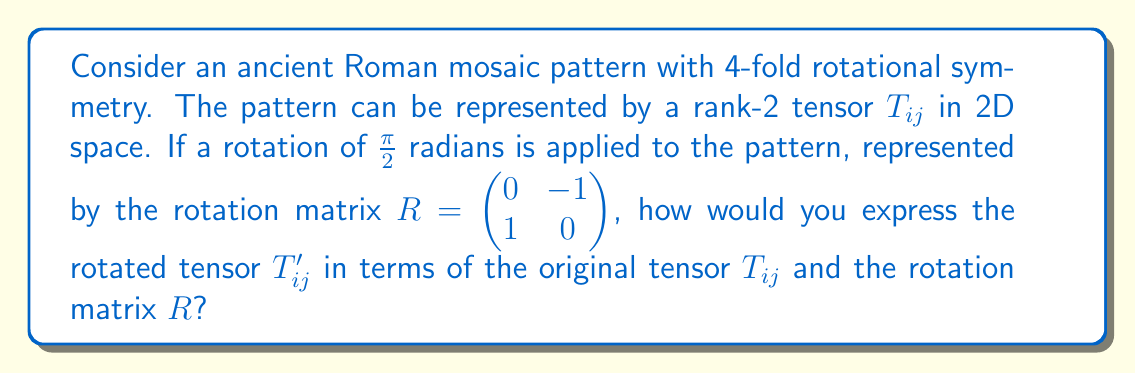Show me your answer to this math problem. To analyze the symmetry of the ancient Roman mosaic pattern using tensor operations, we'll follow these steps:

1) The rotation of a rank-2 tensor $T_{ij}$ by a rotation matrix $R$ is given by the transformation law:

   $$T'_{ij} = R_{im} R_{jn} T_{mn}$$

   Where Einstein summation convention is used (repeated indices are summed over).

2) We're given the rotation matrix $R = \begin{pmatrix} 0 & -1 \\ 1 & 0 \end{pmatrix}$

3) Let's expand the transformation equation:

   $$T'_{ij} = R_{i1} R_{j1} T_{11} + R_{i1} R_{j2} T_{12} + R_{i2} R_{j1} T_{21} + R_{i2} R_{j2} T_{22}$$

4) Now, let's calculate each component of $T'_{ij}$:

   For $T'_{11}$: 
   $$T'_{11} = R_{11} R_{11} T_{11} + R_{11} R_{12} T_{12} + R_{12} R_{11} T_{21} + R_{12} R_{12} T_{22}$$
   $$= (0)(0)T_{11} + (0)(-1)T_{12} + (-1)(0)T_{21} + (-1)(-1)T_{22} = T_{22}$$

   For $T'_{12}$:
   $$T'_{12} = R_{11} R_{21} T_{11} + R_{11} R_{22} T_{12} + R_{12} R_{21} T_{21} + R_{12} R_{22} T_{22}$$
   $$= (0)(1)T_{11} + (0)(0)T_{12} + (-1)(1)T_{21} + (-1)(0)T_{22} = -T_{21}$$

   For $T'_{21}$:
   $$T'_{21} = R_{21} R_{11} T_{11} + R_{21} R_{12} T_{12} + R_{22} R_{11} T_{21} + R_{22} R_{12} T_{22}$$
   $$= (1)(0)T_{11} + (1)(-1)T_{12} + (0)(0)T_{21} + (0)(-1)T_{22} = -T_{12}$$

   For $T'_{22}$:
   $$T'_{22} = R_{21} R_{21} T_{11} + R_{21} R_{22} T_{12} + R_{22} R_{21} T_{21} + R_{22} R_{22} T_{22}$$
   $$= (1)(1)T_{11} + (1)(0)T_{12} + (0)(1)T_{21} + (0)(0)T_{22} = T_{11}$$

5) Therefore, the rotated tensor can be expressed as:

   $$T'_{ij} = \begin{pmatrix} T_{22} & -T_{21} \\ -T_{12} & T_{11} \end{pmatrix}$$

This result shows how the components of the original tensor are rearranged after a $\frac{\pi}{2}$ rotation, reflecting the 4-fold rotational symmetry of the Roman mosaic pattern.
Answer: $$T'_{ij} = \begin{pmatrix} T_{22} & -T_{21} \\ -T_{12} & T_{11} \end{pmatrix}$$ 